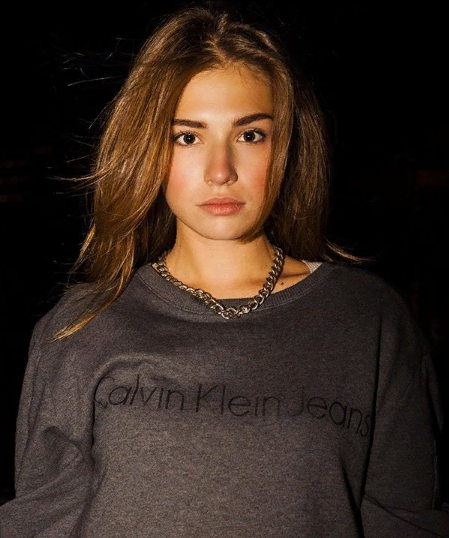Как думаешь какие 7 имён подходят для девушки на фото? Предположительно сколько ей лет? Какие 3 участника корейской группы - BTS нравятся(близки) девушке на фото? Кто ей нравится больше по внешности(красоте лице, красоте глаз) из всех 7 участников BTS? Какие глаза(разрез, форма, тип) каждого участника нравятся моей девушке на фото в процентном соотношении? Кто ей нравится по голосу(вокалу, тембру) - из каждого участников BTS в процентном соотношении? Какие 3 участника BTS наиболее похожи внешне, визуально на мою девушку на фото в процентном соотношении? Какие 3 участника BTS ближе по внешности девушке на фото по её мнению? Какие 3 участника На какие 97 народов(национальностей) похожа внешне(визуально) девушка на фото? На какие 7 типов европеоидной расы и  7 типов монголоидной расы похожа моя девушка на фото? Оцени её красоту и 100-бальной и 10-бальной шкале. Насколько красивое лицо у моей девушки на фото? Какие самые красивые у неё черты лица(глаза, губы, брови, нос, уши)? Какие 11 цветов ей нравятся больше всего и подходят ей по внешности? Какие 11 цифр от 0 до 100 ей нравятся, то есть подходят больше всего и она их любит больше всего? На какие 11 животных  внешне(визуально) похожа девушка на фото? Какие 11 животных ей больше всего нравятся визуально(внешне) и она себя с ними ассоциирует? Пожалуйста, опишите внешность девушки на фото более подробно. Например, опишите форму ее лица, цвет глаз, форму бровей и т.д. Это поможет мне точнее подобрать имена, которые ей подойдут, а также определить ее возраст и другие параметры. 